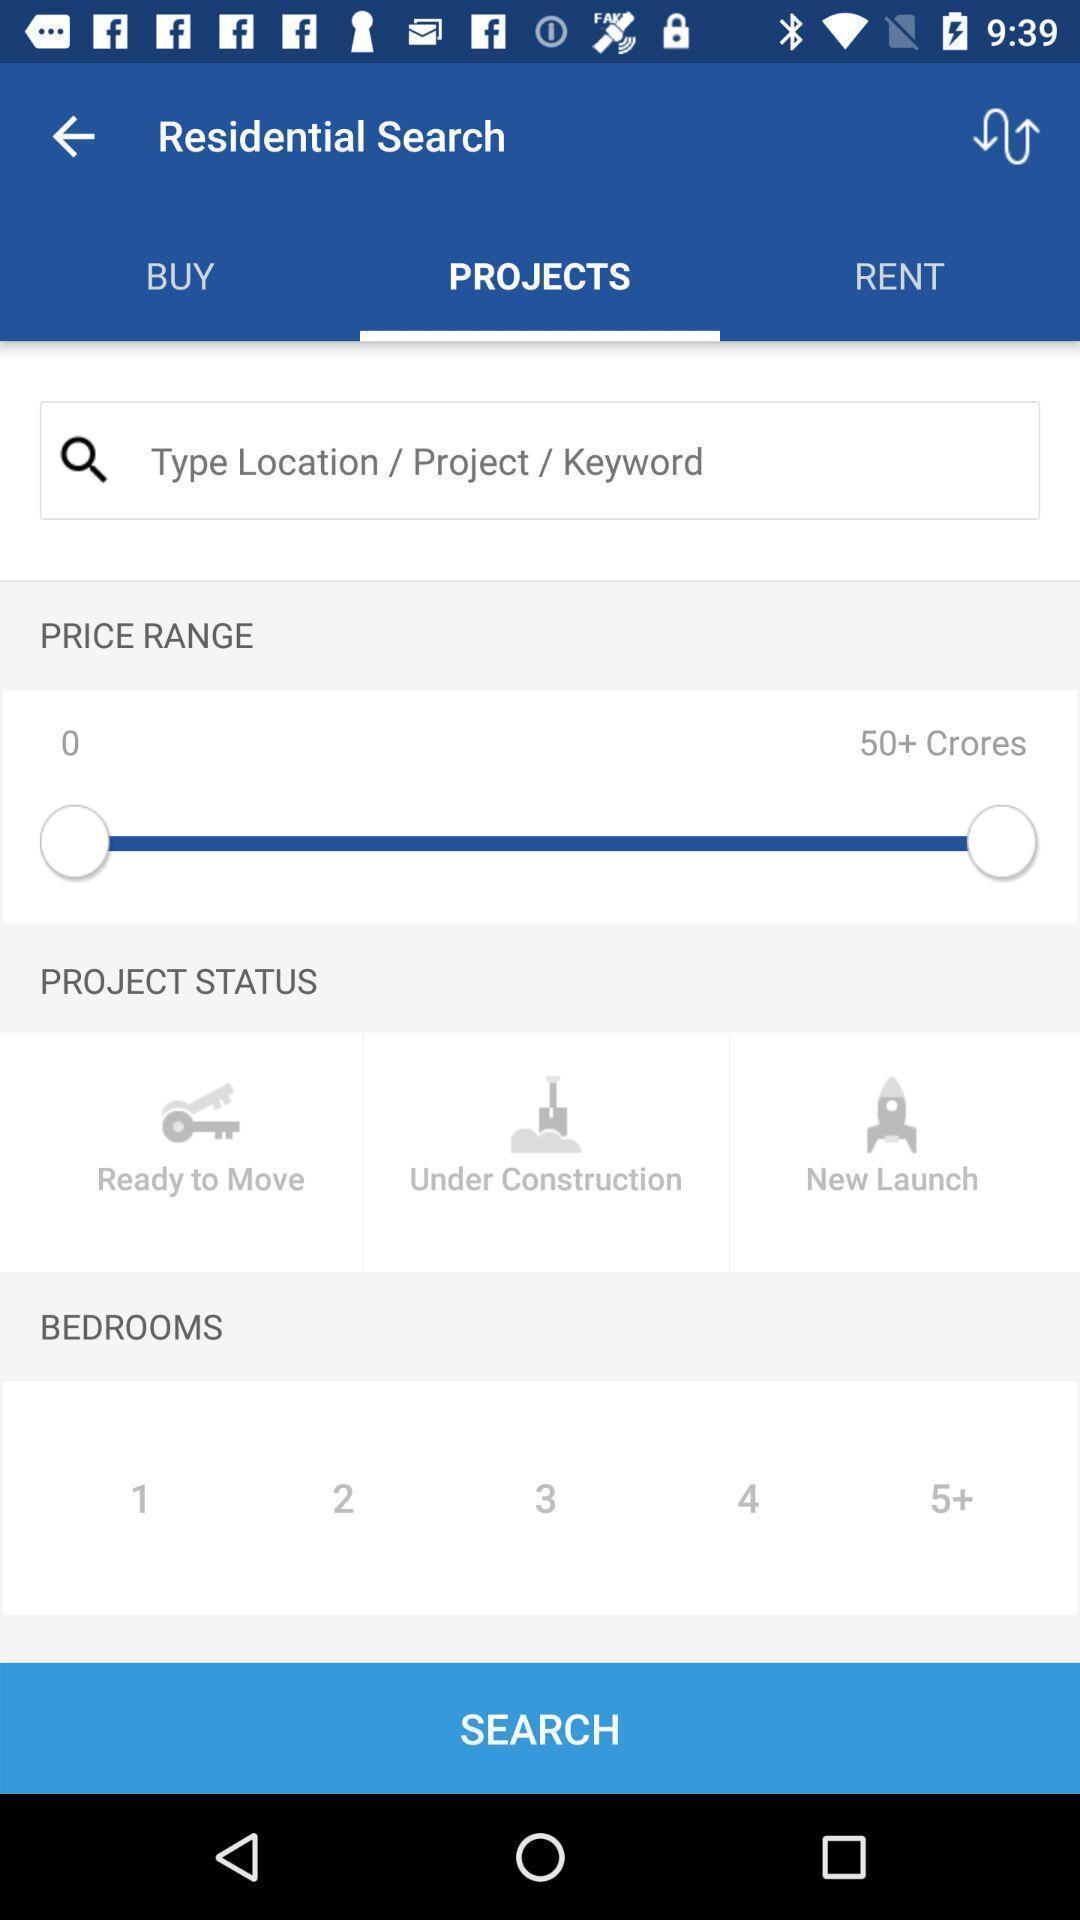Provide a textual representation of this image. Screen shows residential search details. 